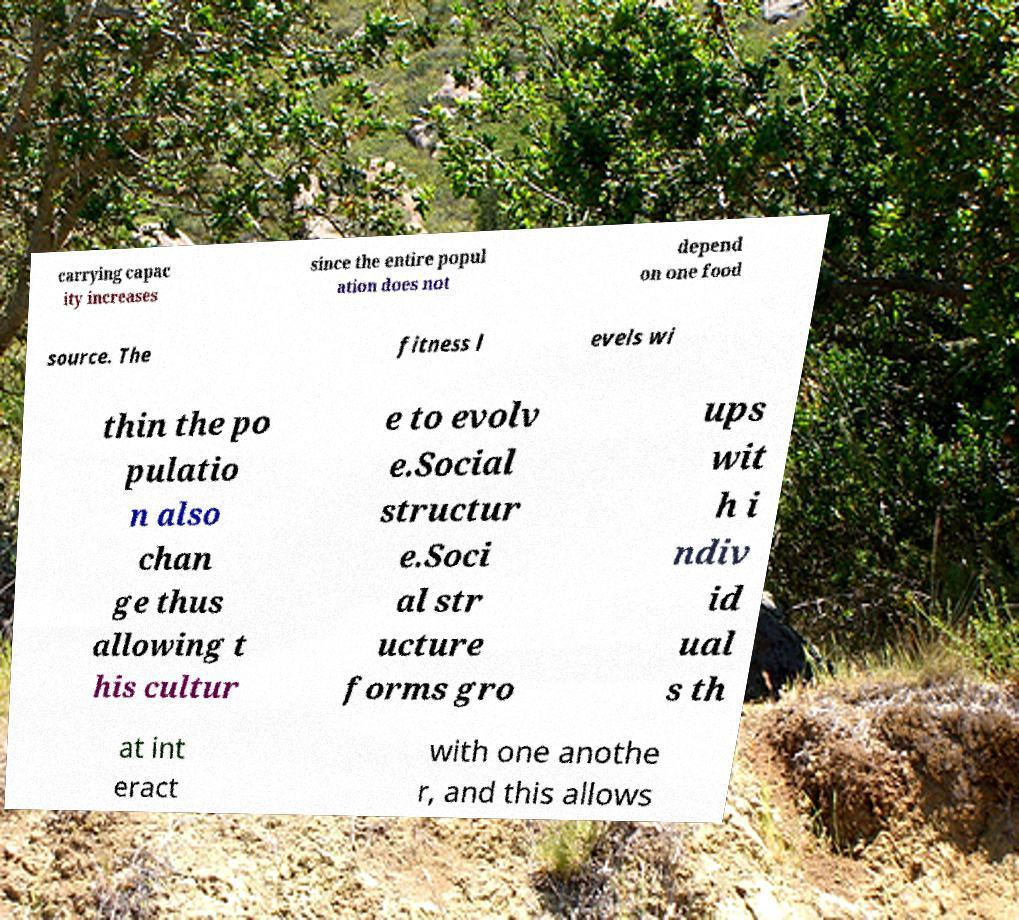There's text embedded in this image that I need extracted. Can you transcribe it verbatim? carrying capac ity increases since the entire popul ation does not depend on one food source. The fitness l evels wi thin the po pulatio n also chan ge thus allowing t his cultur e to evolv e.Social structur e.Soci al str ucture forms gro ups wit h i ndiv id ual s th at int eract with one anothe r, and this allows 